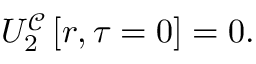<formula> <loc_0><loc_0><loc_500><loc_500>U _ { 2 } ^ { \mathcal { C } } \left [ r , \tau = 0 \right ] = 0 .</formula> 